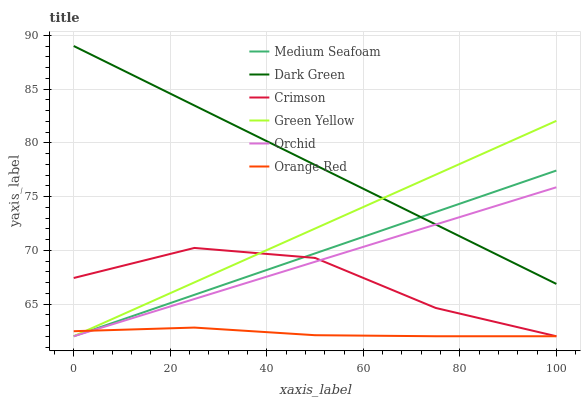Does Orange Red have the minimum area under the curve?
Answer yes or no. Yes. Does Dark Green have the maximum area under the curve?
Answer yes or no. Yes. Does Crimson have the minimum area under the curve?
Answer yes or no. No. Does Crimson have the maximum area under the curve?
Answer yes or no. No. Is Dark Green the smoothest?
Answer yes or no. Yes. Is Crimson the roughest?
Answer yes or no. Yes. Is Orange Red the smoothest?
Answer yes or no. No. Is Orange Red the roughest?
Answer yes or no. No. Does Orange Red have the lowest value?
Answer yes or no. Yes. Does Dark Green have the highest value?
Answer yes or no. Yes. Does Crimson have the highest value?
Answer yes or no. No. Is Crimson less than Dark Green?
Answer yes or no. Yes. Is Dark Green greater than Orange Red?
Answer yes or no. Yes. Does Orange Red intersect Orchid?
Answer yes or no. Yes. Is Orange Red less than Orchid?
Answer yes or no. No. Is Orange Red greater than Orchid?
Answer yes or no. No. Does Crimson intersect Dark Green?
Answer yes or no. No. 